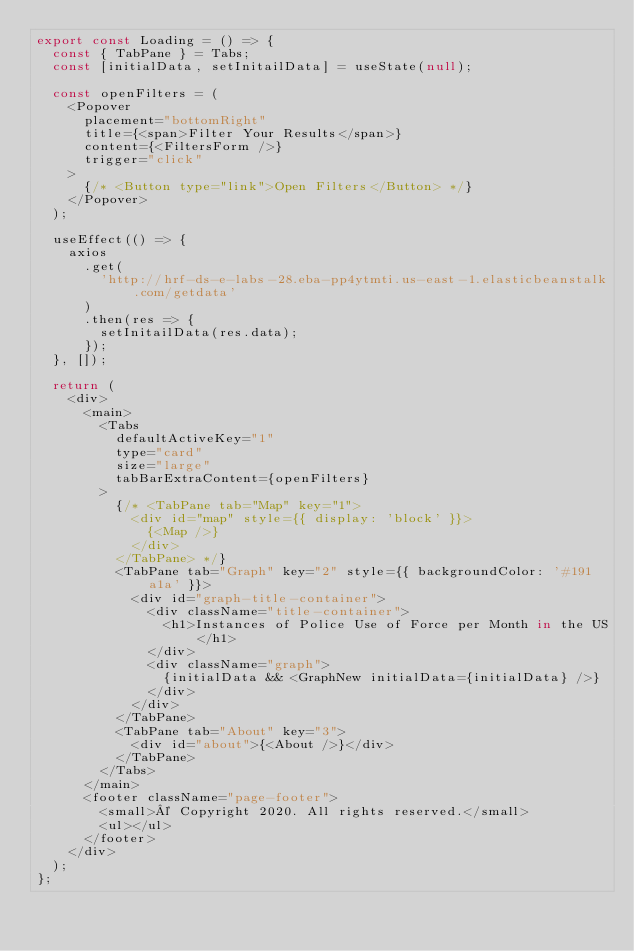<code> <loc_0><loc_0><loc_500><loc_500><_JavaScript_>export const Loading = () => {
  const { TabPane } = Tabs;
  const [initialData, setInitailData] = useState(null);

  const openFilters = (
    <Popover
      placement="bottomRight"
      title={<span>Filter Your Results</span>}
      content={<FiltersForm />}
      trigger="click"
    >
      {/* <Button type="link">Open Filters</Button> */}
    </Popover>
  );

  useEffect(() => {
    axios
      .get(
        'http://hrf-ds-e-labs-28.eba-pp4ytmti.us-east-1.elasticbeanstalk.com/getdata'
      )
      .then(res => {
        setInitailData(res.data);
      });
  }, []);

  return (
    <div>
      <main>
        <Tabs
          defaultActiveKey="1"
          type="card"
          size="large"
          tabBarExtraContent={openFilters}
        >
          {/* <TabPane tab="Map" key="1">
            <div id="map" style={{ display: 'block' }}>
              {<Map />}
            </div>
          </TabPane> */}
          <TabPane tab="Graph" key="2" style={{ backgroundColor: '#191a1a' }}>
            <div id="graph-title-container">
              <div className="title-container">
                <h1>Instances of Police Use of Force per Month in the US</h1>
              </div>
              <div className="graph">
                {initialData && <GraphNew initialData={initialData} />}
              </div>
            </div>
          </TabPane>
          <TabPane tab="About" key="3">
            <div id="about">{<About />}</div>
          </TabPane>
        </Tabs>
      </main>
      <footer className="page-footer">
        <small>© Copyright 2020. All rights reserved.</small>
        <ul></ul>
      </footer>
    </div>
  );
};
</code> 